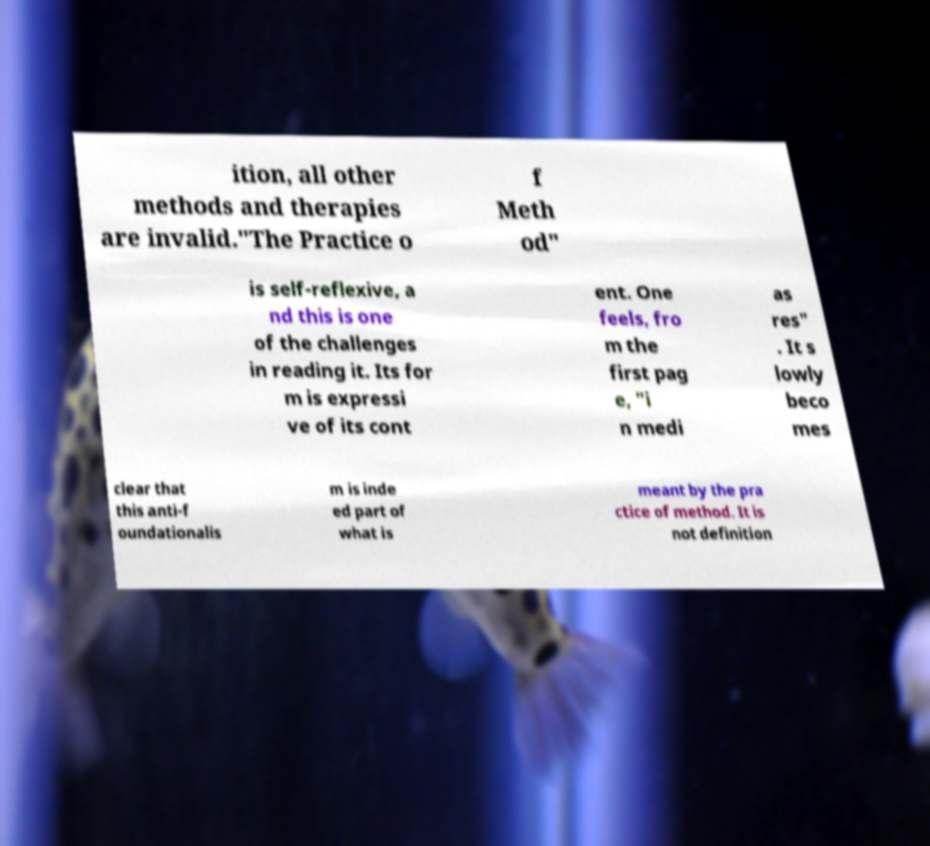What messages or text are displayed in this image? I need them in a readable, typed format. ition, all other methods and therapies are invalid."The Practice o f Meth od" is self-reflexive, a nd this is one of the challenges in reading it. Its for m is expressi ve of its cont ent. One feels, fro m the first pag e, "i n medi as res" . It s lowly beco mes clear that this anti-f oundationalis m is inde ed part of what is meant by the pra ctice of method. It is not definition 